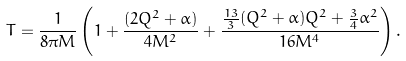Convert formula to latex. <formula><loc_0><loc_0><loc_500><loc_500>T = \frac { 1 } { 8 \pi M } \left ( 1 + \frac { ( 2 Q ^ { 2 } + \alpha ) } { 4 M ^ { 2 } } + \frac { \frac { 1 3 } { 3 } ( Q ^ { 2 } + \alpha ) Q ^ { 2 } + \frac { 3 } { 4 } \alpha ^ { 2 } } { 1 6 M ^ { 4 } } \right ) .</formula> 